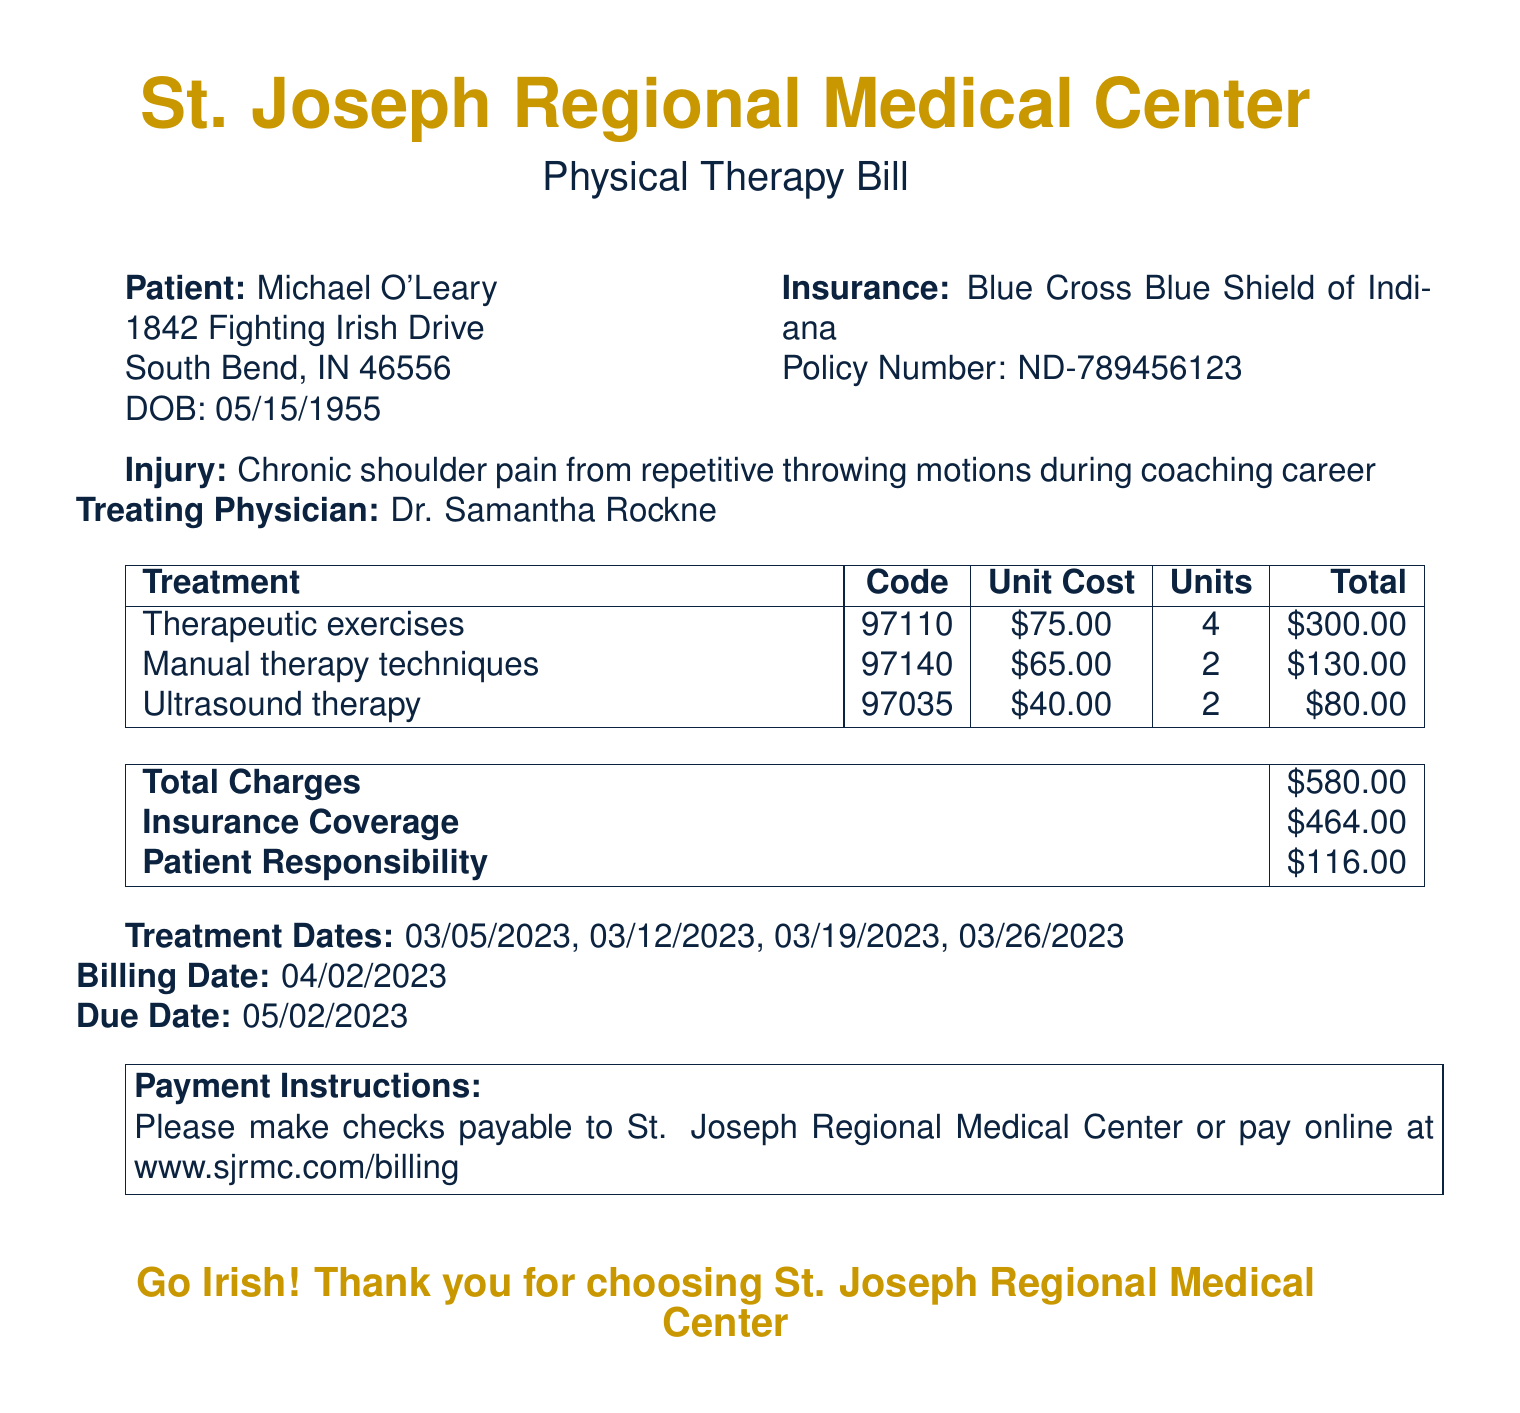What is the patient's name? The patient's name is provided at the beginning of the document as Michael O'Leary.
Answer: Michael O'Leary What is the total charge for the treatments? The total charge is stated in the document under "Total Charges," which is $580.00.
Answer: $580.00 What is the patient responsibility amount? The patient responsibility amount is found under "Patient Responsibility," which states $116.00.
Answer: $116.00 Who is the treating physician? The treating physician's name is mentioned in the document, which is Dr. Samantha Rockne.
Answer: Dr. Samantha Rockne What is the insurance company name? The insurance company name is found in the insurance details, listed as Blue Cross Blue Shield of Indiana.
Answer: Blue Cross Blue Shield of Indiana How many units of therapeutic exercises were billed? The units for therapeutic exercises are indicated in the treatment table as 4 units.
Answer: 4 What treatment was associated with the code 97035? The treatment associated with the code 97035 is listed in the document as Ultrasound therapy.
Answer: Ultrasound therapy What is the due date for payment? The due date for payment is specified in the document as May 2, 2023.
Answer: May 2, 2023 What are the treatment dates? The treatment dates are listed together as March 5, 2023, March 12, 2023, March 19, 2023, and March 26, 2023.
Answer: March 5, 2023, March 12, 2023, March 19, 2023, March 26, 2023 